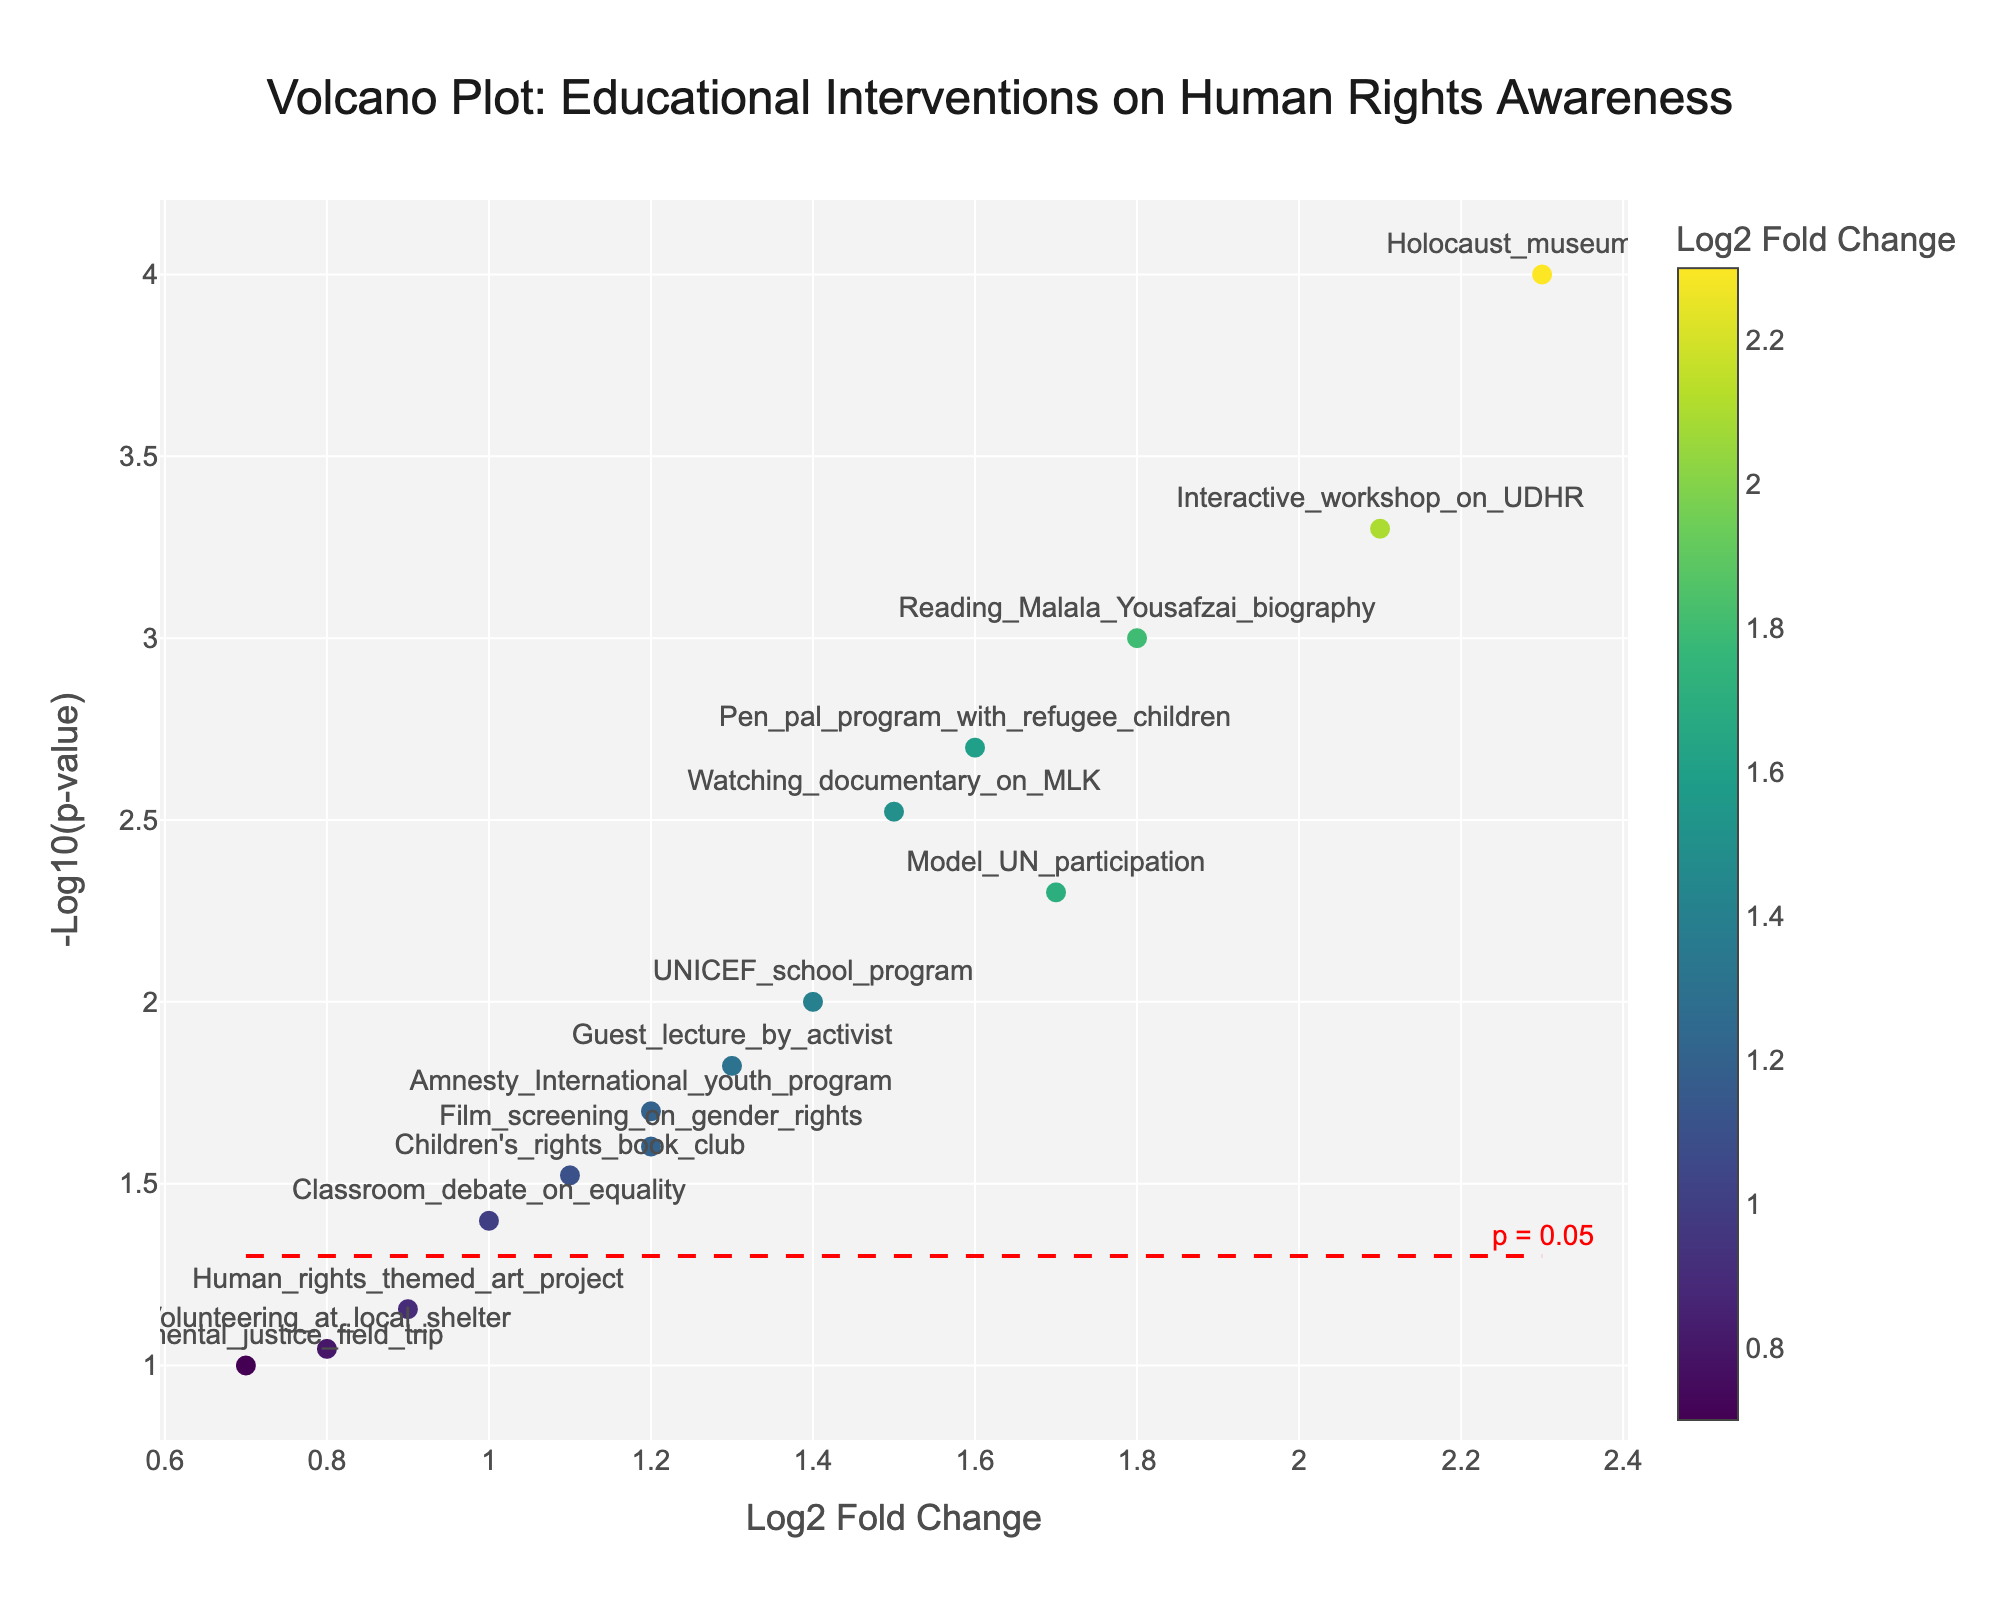What is the title of the figure? The title is directly shown at the top of the plot and provides a summary of what the figure represents.
Answer: Volcano Plot: Educational Interventions on Human Rights Awareness Which intervention has the highest log2 fold change? By looking at the x-axis, we can see that the data point farthest to the right has the highest log2 fold change, which is labeled as Holocaust_museum_visit.
Answer: Holocaust_museum_visit What is the p-value threshold indicated by the red dashed line? The red dashed line represents the significance threshold, which is commonly set at p = 0.05. This is indicated by the annotation at the end of the line.
Answer: 0.05 How many interventions have a p-value less than or equal to 0.05? To find this, we need to count the number of data points above the red dashed line, meaning they have a -log10(p-value) greater than or equal to -log10(0.05). There are 10 such points.
Answer: 10 Which intervention has a log2 fold change closest to 1.0? By checking the x-axis for the data point closest to 1.0, we find that Classroom_debate_on_equality is the closest intervention.
Answer: Classroom_debate_on_equality Which intervention has the highest statistical significance? Statistical significance is judged by the -log10(p-value) on the y-axis. The intervention with the highest y-value is Holocaust_museum_visit.
Answer: Holocaust_museum_visit Compare the log2 fold changes of Reading_Malala_Yousafzai_biography and Watching_documentary_on_MLK. Which one is higher? By locating both interventions on the x-axis, Reading_Malala_Yousafzai_biography has a log2 fold change of 1.8 and Watching_documentary_on_MLK has 1.5. Therefore, Reading_Malala_Yousafzai_biography is higher.
Answer: Reading_Malala_Yousafzai_biography What is the -log10(p-value) for the Guest_lecture_by_activist intervention? This information is displayed by looking at the position of the Guest_lecture_by_activist data point on the y-axis; its exact value can be calculated using its p-value of 0.015, which gives approximately 1.8239.
Answer: 1.8239 Which interventions have both high log2 fold change and high statistical significance? Interventions in the top right quadrant of the plot meet this condition, including Holocaust_museum_visit, Interactive_workshop_on_UDHR, and Reading_Malala_Yousafzai_biography. These interventions have both high x-axis values and y-axis values.
Answer: Holocaust_museum_visit, Interactive_workshop_on_UDHR, Reading_Malala_Yousafzai_biography 